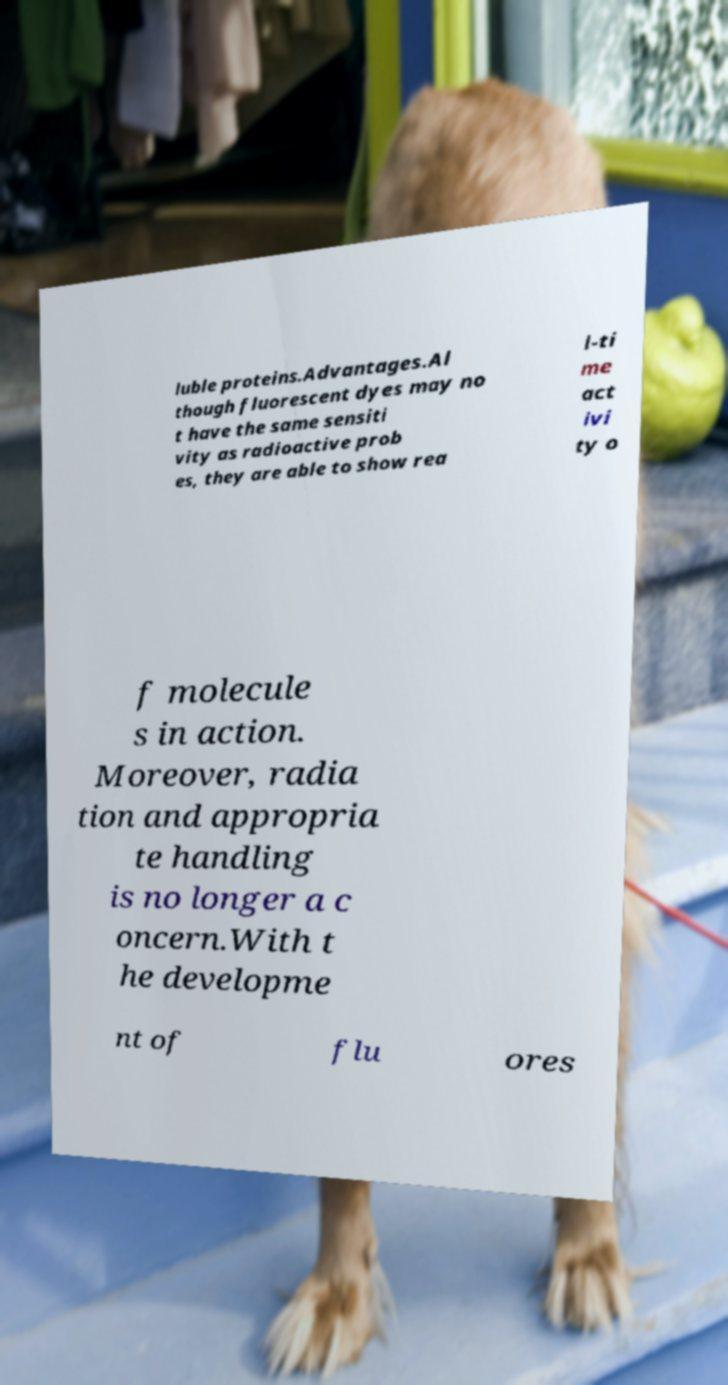Please identify and transcribe the text found in this image. luble proteins.Advantages.Al though fluorescent dyes may no t have the same sensiti vity as radioactive prob es, they are able to show rea l-ti me act ivi ty o f molecule s in action. Moreover, radia tion and appropria te handling is no longer a c oncern.With t he developme nt of flu ores 